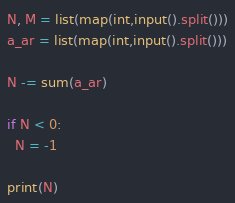<code> <loc_0><loc_0><loc_500><loc_500><_Python_>N, M = list(map(int,input().split()))
a_ar = list(map(int,input().split()))

N -= sum(a_ar)

if N < 0:
  N = -1

print(N)</code> 